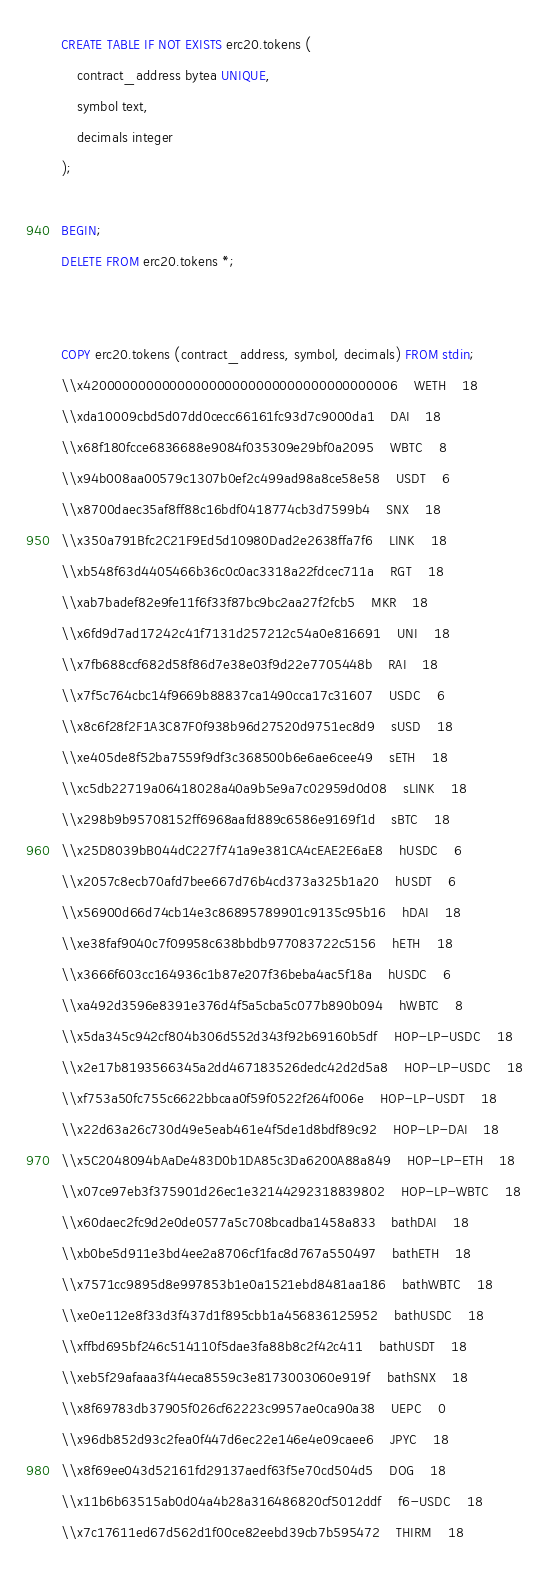Convert code to text. <code><loc_0><loc_0><loc_500><loc_500><_SQL_>CREATE TABLE IF NOT EXISTS erc20.tokens (
	contract_address bytea UNIQUE,
	symbol text,
	decimals integer
);

BEGIN;
DELETE FROM erc20.tokens *;


COPY erc20.tokens (contract_address, symbol, decimals) FROM stdin;
\\x4200000000000000000000000000000000000006	WETH	18
\\xda10009cbd5d07dd0cecc66161fc93d7c9000da1	DAI	18
\\x68f180fcce6836688e9084f035309e29bf0a2095	WBTC	8
\\x94b008aa00579c1307b0ef2c499ad98a8ce58e58	USDT	6
\\x8700daec35af8ff88c16bdf0418774cb3d7599b4	SNX	18
\\x350a791Bfc2C21F9Ed5d10980Dad2e2638ffa7f6	LINK	18
\\xb548f63d4405466b36c0c0ac3318a22fdcec711a	RGT	18
\\xab7badef82e9fe11f6f33f87bc9bc2aa27f2fcb5	MKR	18
\\x6fd9d7ad17242c41f7131d257212c54a0e816691	UNI	18
\\x7fb688ccf682d58f86d7e38e03f9d22e7705448b	RAI	18
\\x7f5c764cbc14f9669b88837ca1490cca17c31607	USDC	6
\\x8c6f28f2F1A3C87F0f938b96d27520d9751ec8d9	sUSD	18
\\xe405de8f52ba7559f9df3c368500b6e6ae6cee49	sETH	18
\\xc5db22719a06418028a40a9b5e9a7c02959d0d08	sLINK	18
\\x298b9b95708152ff6968aafd889c6586e9169f1d	sBTC	18
\\x25D8039bB044dC227f741a9e381CA4cEAE2E6aE8	hUSDC	6
\\x2057c8ecb70afd7bee667d76b4cd373a325b1a20	hUSDT	6
\\x56900d66d74cb14e3c86895789901c9135c95b16	hDAI	18
\\xe38faf9040c7f09958c638bbdb977083722c5156	hETH	18
\\x3666f603cc164936c1b87e207f36beba4ac5f18a	hUSDC	6
\\xa492d3596e8391e376d4f5a5cba5c077b890b094	hWBTC	8
\\x5da345c942cf804b306d552d343f92b69160b5df	HOP-LP-USDC	18
\\x2e17b8193566345a2dd467183526dedc42d2d5a8	HOP-LP-USDC	18
\\xf753a50fc755c6622bbcaa0f59f0522f264f006e	HOP-LP-USDT	18
\\x22d63a26c730d49e5eab461e4f5de1d8bdf89c92	HOP-LP-DAI	18
\\x5C2048094bAaDe483D0b1DA85c3Da6200A88a849	HOP-LP-ETH	18
\\x07ce97eb3f375901d26ec1e32144292318839802	HOP-LP-WBTC	18
\\x60daec2fc9d2e0de0577a5c708bcadba1458a833	bathDAI	18
\\xb0be5d911e3bd4ee2a8706cf1fac8d767a550497	bathETH	18
\\x7571cc9895d8e997853b1e0a1521ebd8481aa186	bathWBTC	18
\\xe0e112e8f33d3f437d1f895cbb1a456836125952	bathUSDC	18
\\xffbd695bf246c514110f5dae3fa88b8c2f42c411	bathUSDT	18
\\xeb5f29afaaa3f44eca8559c3e8173003060e919f	bathSNX	18
\\x8f69783db37905f026cf62223c9957ae0ca90a38	UEPC	0
\\x96db852d93c2fea0f447d6ec22e146e4e09caee6	JPYC	18
\\x8f69ee043d52161fd29137aedf63f5e70cd504d5	DOG	18
\\x11b6b63515ab0d04a4b28a316486820cf5012ddf	f6-USDC	18
\\x7c17611ed67d562d1f00ce82eebd39cb7b595472	THIRM	18</code> 